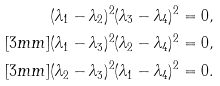<formula> <loc_0><loc_0><loc_500><loc_500>& ( \lambda _ { 1 } - \lambda _ { 2 } ) ^ { 2 } ( \lambda _ { 3 } - \lambda _ { 4 } ) ^ { 2 } = 0 , \\ [ 3 m m ] & ( \lambda _ { 1 } - \lambda _ { 3 } ) ^ { 2 } ( \lambda _ { 2 } - \lambda _ { 4 } ) ^ { 2 } = 0 , \\ [ 3 m m ] & ( \lambda _ { 2 } - \lambda _ { 3 } ) ^ { 2 } ( \lambda _ { 1 } - \lambda _ { 4 } ) ^ { 2 } = 0 .</formula> 